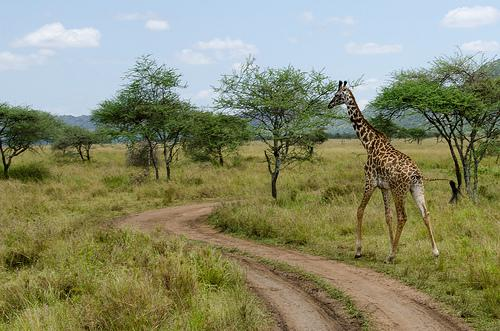Question: where is the giraffe standing?
Choices:
A. Near the food.
B. Beside the fence.
C. The grass.
D. Near the baby giraffe.
Answer with the letter. Answer: C Question: who is next to the road?
Choices:
A. The sidewalk.
B. Grass.
C. The giraffe.
D. The trees.
Answer with the letter. Answer: C Question: what type of road is in the picture?
Choices:
A. Gravel.
B. Asphalt.
C. Cobblestone.
D. Dirt.
Answer with the letter. Answer: D Question: where are the clouds?
Choices:
A. Behind the trees.
B. Over the mountains.
C. On the horizon.
D. The sky.
Answer with the letter. Answer: D Question: what is behind the trees?
Choices:
A. Clouds.
B. Cornfields.
C. A lake.
D. Mountains.
Answer with the letter. Answer: D Question: what is growing in the grass?
Choices:
A. Flowers.
B. Trees.
C. Mushrooms.
D. Weeds.
Answer with the letter. Answer: B 